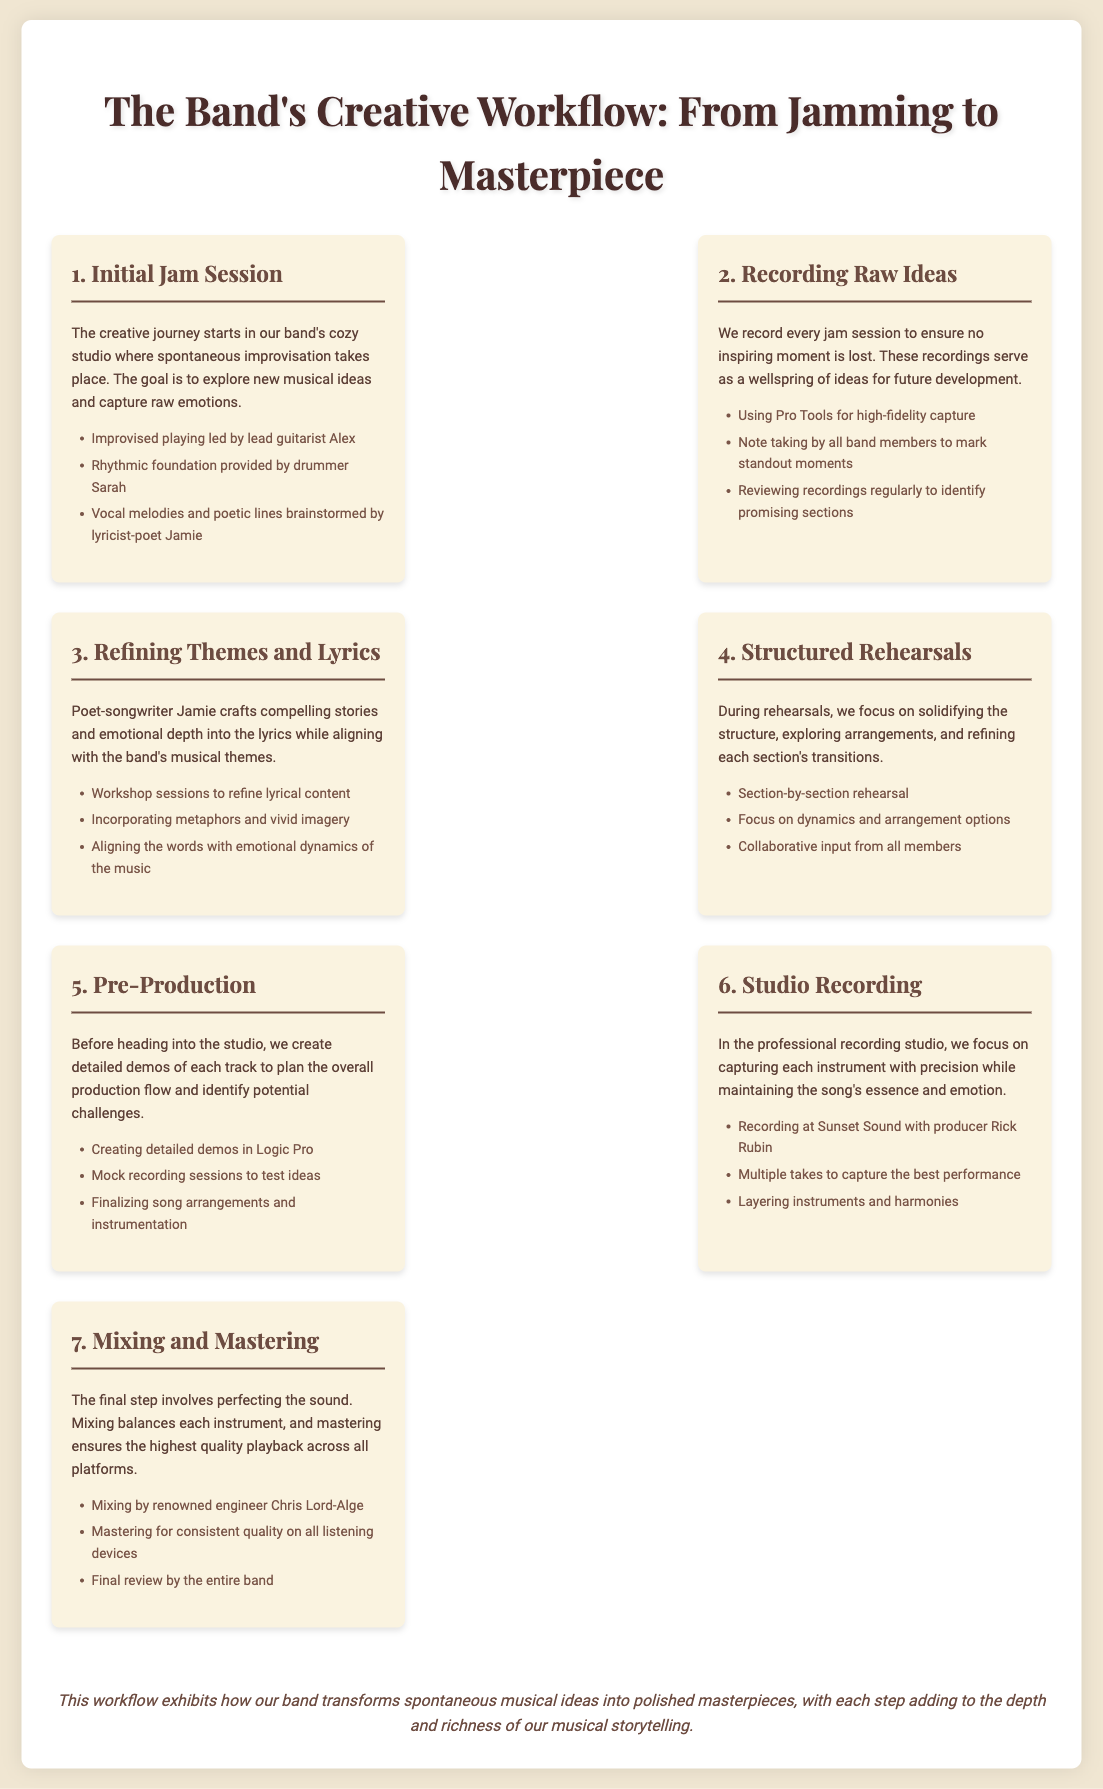What is the first step in the creative workflow? The first step in the creative workflow is described as the Initial Jam Session where spontaneous improvisation takes place.
Answer: Initial Jam Session Who provides the rhythmic foundation during the jam session? The document specifies that the rhythmic foundation is provided by drummer Sarah.
Answer: drummer Sarah What tool is used for recording raw ideas? The document mentions using Pro Tools for high-fidelity capture during the recording of raw ideas.
Answer: Pro Tools Which member focuses on crafting lyrics? The lyricist-poet Jamie is the member who crafts compelling stories and emotional depth into the lyrics.
Answer: Jamie What is produced during the Pre-Production step? In the Pre-Production step, detailed demos of each track are created to plan the overall production flow.
Answer: detailed demos Who is the producer during the studio recording? The document lists Rick Rubin as the producer during the studio recording at Sunset Sound.
Answer: Rick Rubin What is the final step of the creative workflow? The final step mentioned in the workflow involves Mixing and Mastering to perfect the sound.
Answer: Mixing and Mastering Which engineer is responsible for mixing? Renowned engineer Chris Lord-Alge is responsible for mixing.
Answer: Chris Lord-Alge What does the workflow ultimately exhibit? The workflow exhibits how the band transforms spontaneous musical ideas into polished masterpieces.
Answer: polished masterpieces 